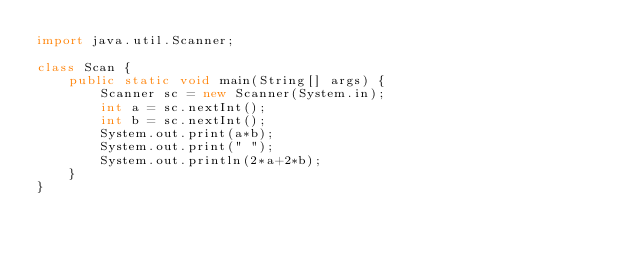Convert code to text. <code><loc_0><loc_0><loc_500><loc_500><_Java_>import java.util.Scanner;
 
class Scan {
    public static void main(String[] args) {
        Scanner sc = new Scanner(System.in);
        int a = sc.nextInt();
        int b = sc.nextInt();
        System.out.print(a*b);
        System.out.print(" ");
        System.out.println(2*a+2*b);
    }
}
 </code> 